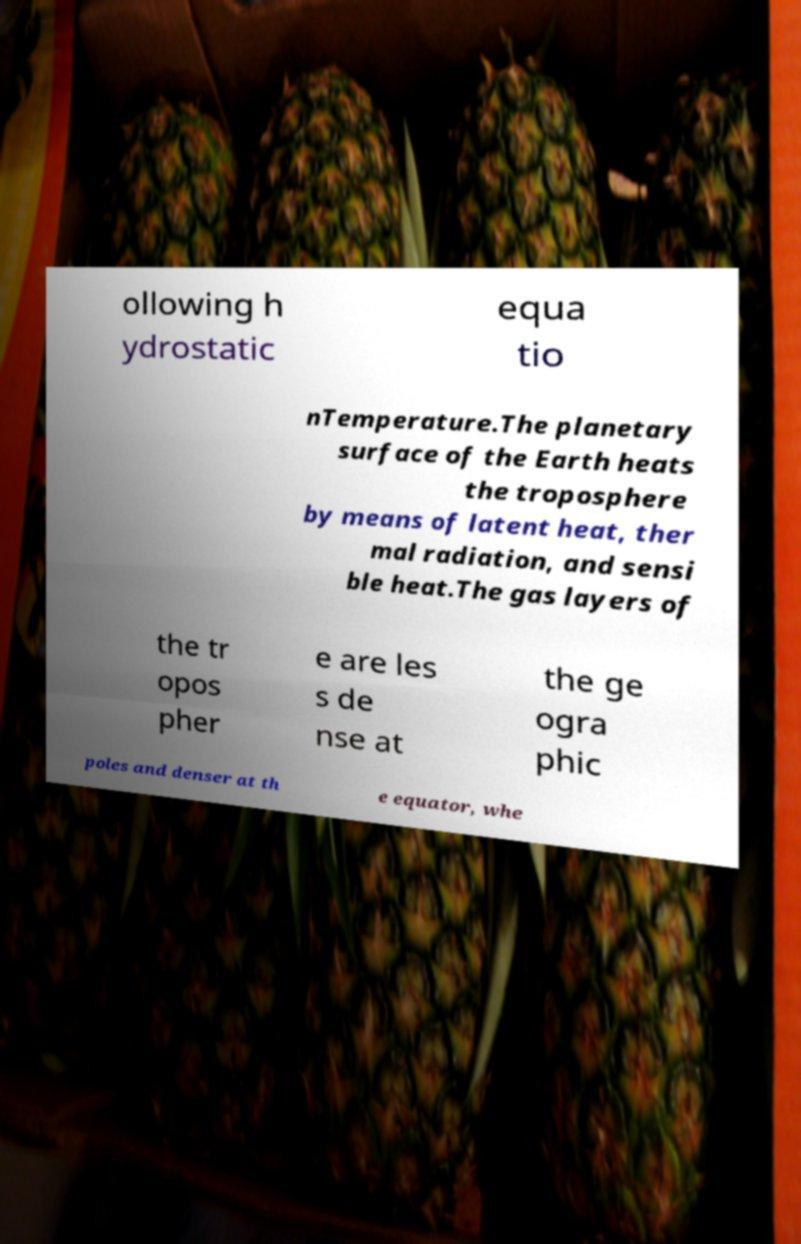Can you accurately transcribe the text from the provided image for me? ollowing h ydrostatic equa tio nTemperature.The planetary surface of the Earth heats the troposphere by means of latent heat, ther mal radiation, and sensi ble heat.The gas layers of the tr opos pher e are les s de nse at the ge ogra phic poles and denser at th e equator, whe 